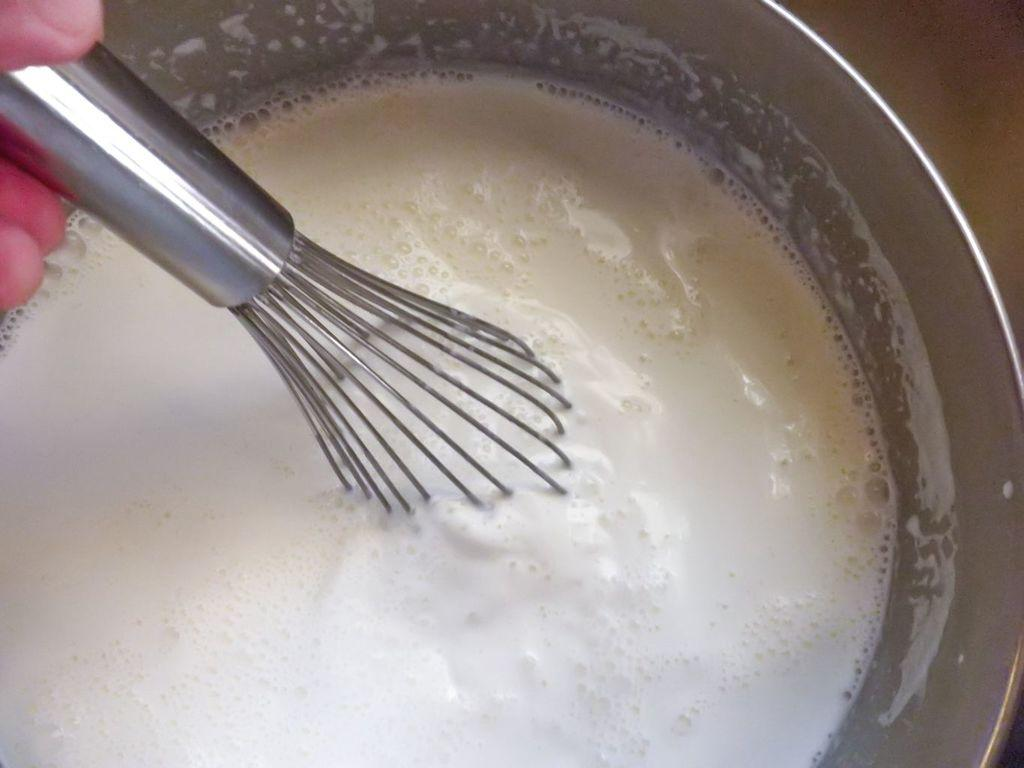What is the main object in the image? There is an egg beater in the image. What is the egg beater doing or in what state is it in the image? The egg beater is in a liquid. Where is the liquid located? The liquid is in a jar. Who is holding the jar? The jar is held in a person's hand. How many frogs are sitting on the egg beater in the image? There are no frogs present in the image. What type of fish can be seen swimming in the liquid with the egg beater? There are no fish present in the image; the liquid contains only the egg beater. 